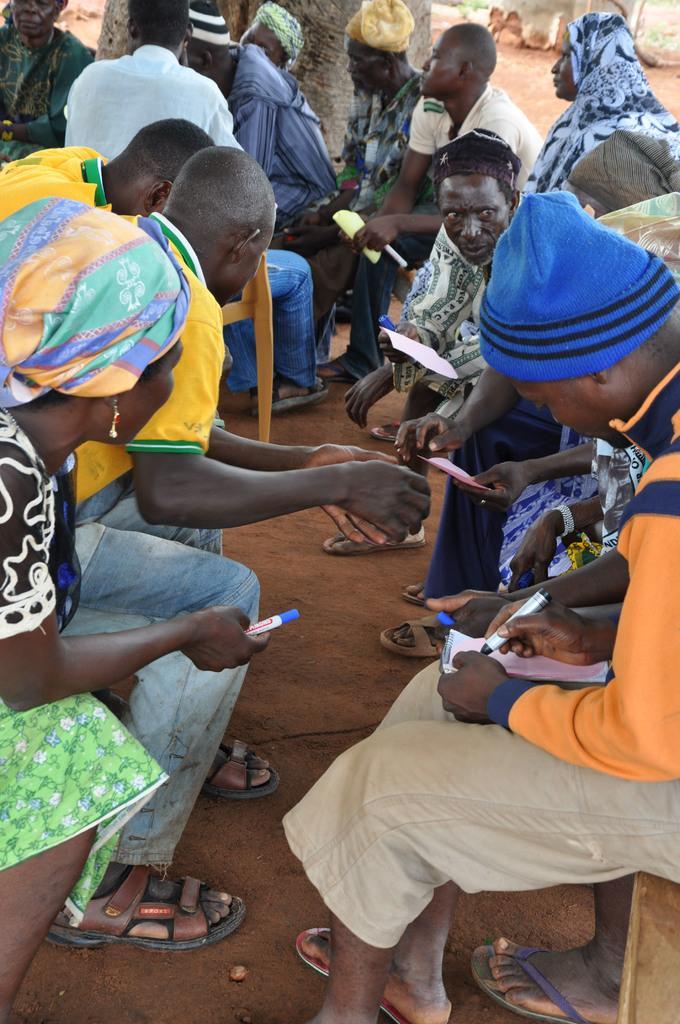How would you summarize this image in a sentence or two? In this picture there are group of people on the right and left side of the image, by holding papers in their hands, there is a tree at the top side of the image. 